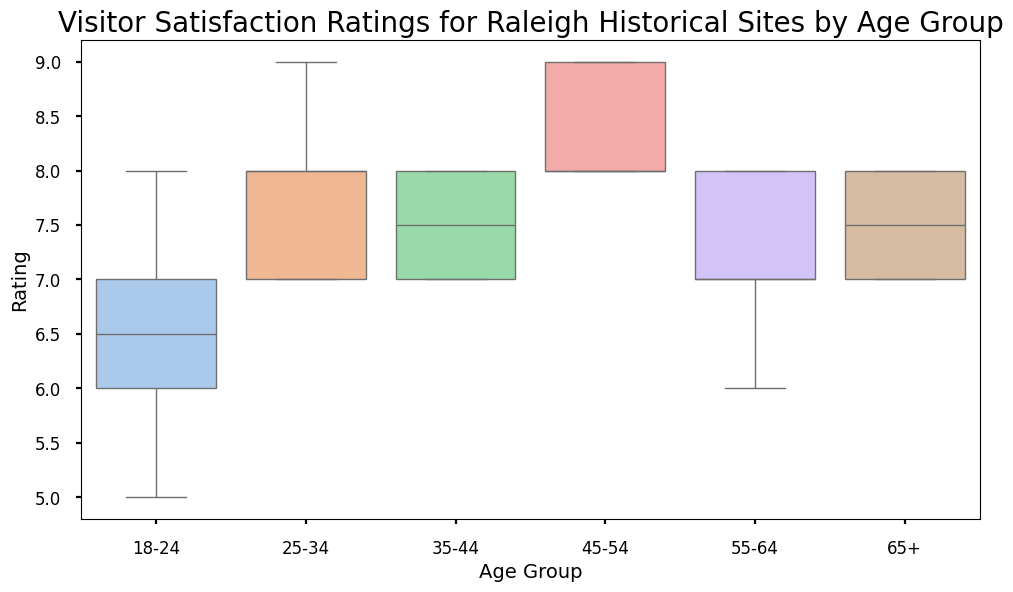What's the median satisfaction rating for the 18-24 age group? The box plot's line within the 18-24 age group's box represents the median, which falls at around 6.5. Therefore, the median satisfaction rating for the 18-24 age group is approximately 6.5.
Answer: 6.5 Which age group has the highest median satisfaction rating? By examining the middle lines of the boxes, the 45-54 age group has the highest median satisfaction rating, which appears to be closest to 8.5.
Answer: 45-54 Are there any age groups with the same median satisfaction rating? The box plots for the 25-34 and 35-44 age groups both have their medians at the same level, which is approximately 7.5. Thus, these two age groups share the same median rating.
Answer: 25-34 and 35-44 Which age group's satisfaction ratings have the smallest interquartile range (IQR)? The IQR is the range between the first (Q1) and third quartiles (Q3). The 45-54 age group's box is the narrowest, indicating the smallest IQR.
Answer: 45-54 Are there any outliers in the satisfaction ratings for any age group? Outliers are usually represented by individual points outside the whiskers. By observing the plot, there are no points outside the whiskers, indicating that there are no outliers in any of the age groups.
Answer: No Which age group's ratings have the widest range? The range is the distance between the minimum and maximum whiskers. The 18-24 age group has the widest range because its whiskers extend the furthest apart.
Answer: 18-24 How does the median satisfaction rating for the 65+ age group compare to the 55-64 age group? By comparing the middle lines of the boxes, the median rating for the 65+ age group is slightly below that of the 55-64 age group, which is around 7.5 for both groups.
Answer: Similar Which age group has the highest minimum satisfaction rating? The minimum rating is represented by the bottom whisker. The 45-54 age group has the highest minimum rating, which is around 8.
Answer: 45-54 What is the upper quartile (Q3) for the satisfaction ratings in the 25-34 age group? The upper quartile is the top of the box. For the 25-34 age group, it is around 8, indicating that 75% of the ratings are below this value.
Answer: 8 What is the median and IQR for the 55-64 age group? The IQR is the range between Q1 and Q3. For the 55-64 age group, the median is about 7.5. The IQR is the range from Q1 (around 7) to Q3 (around 8), so the IQR is 1.
Answer: Median: 7.5, IQR: 1 